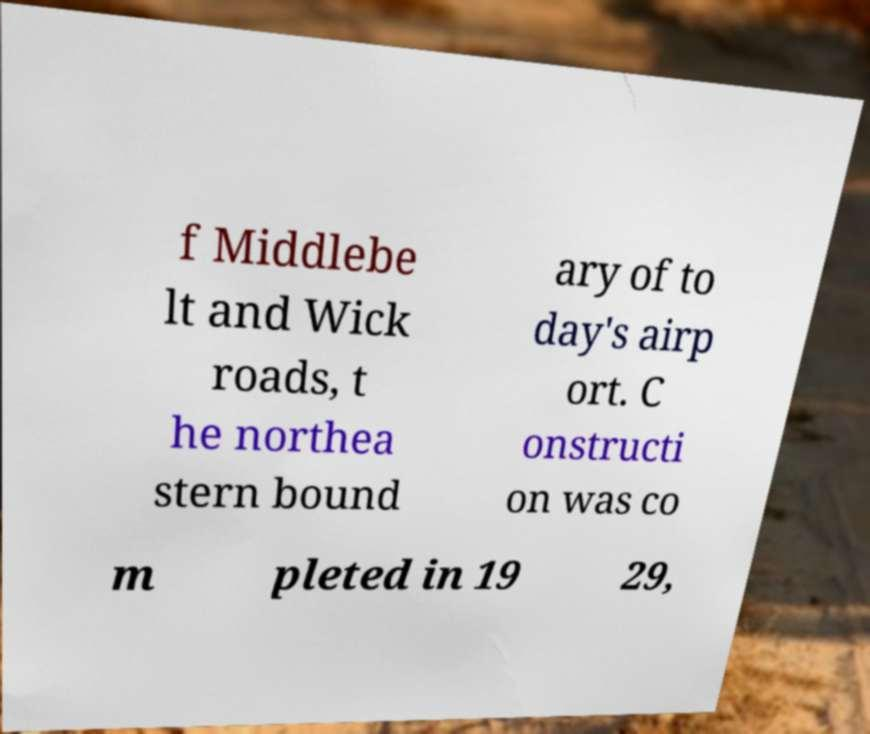For documentation purposes, I need the text within this image transcribed. Could you provide that? f Middlebe lt and Wick roads, t he northea stern bound ary of to day's airp ort. C onstructi on was co m pleted in 19 29, 